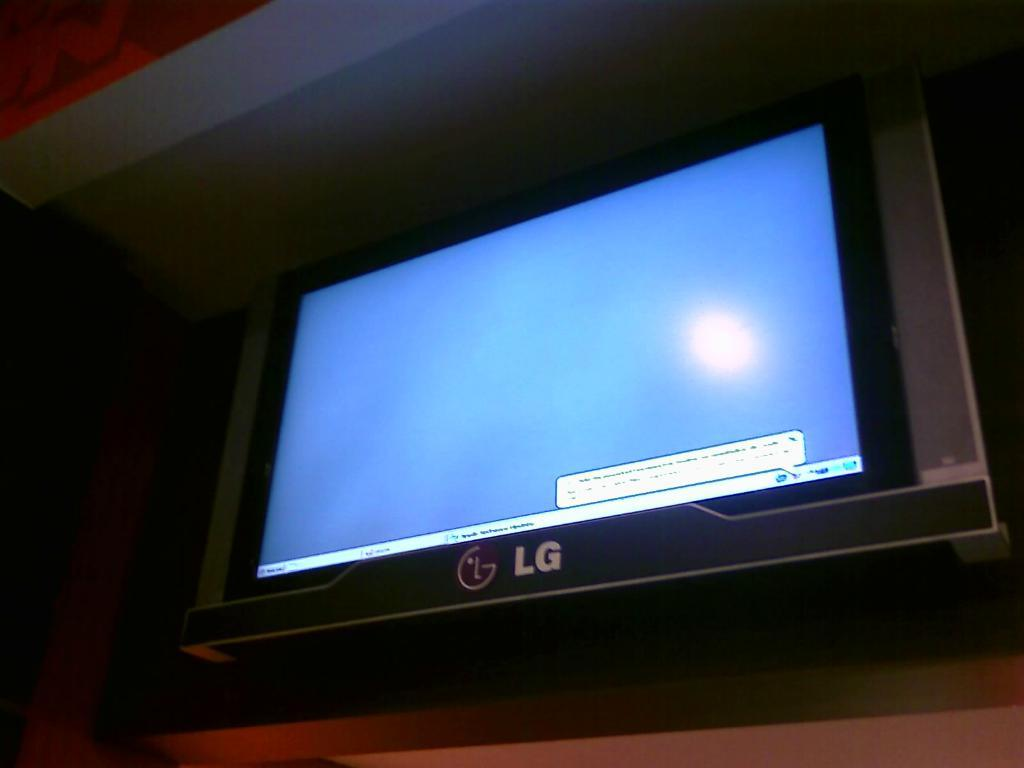<image>
Provide a brief description of the given image. An LG screen is lit but has no picture. 